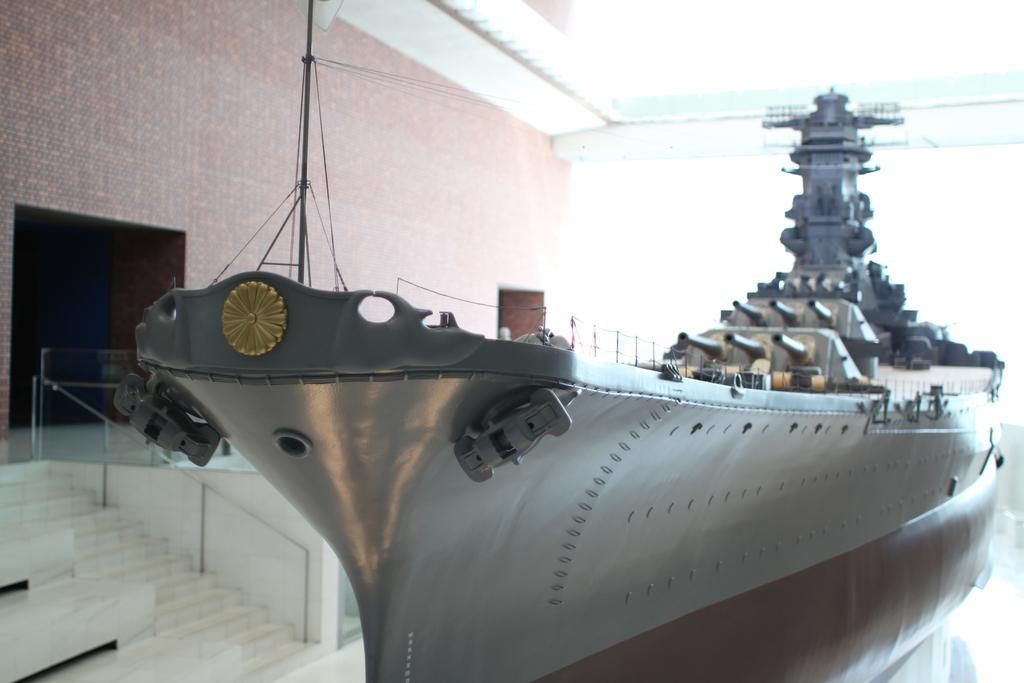Please provide a concise description of this image. In this image we can see a ship with some metal poles and cables. On the left side of the image we can see a building, staircase and a railing. 